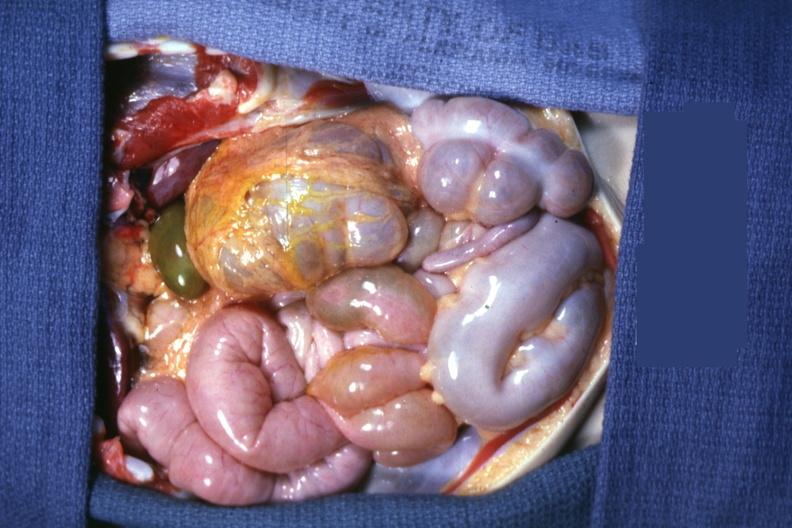s tuberculous peritonitis present?
Answer the question using a single word or phrase. No 